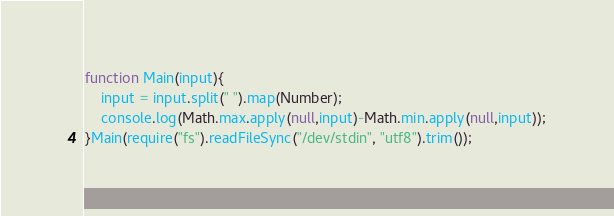<code> <loc_0><loc_0><loc_500><loc_500><_JavaScript_>function Main(input){
	input = input.split(" ").map(Number);
	console.log(Math.max.apply(null,input)-Math.min.apply(null,input));
}Main(require("fs").readFileSync("/dev/stdin", "utf8").trim());</code> 